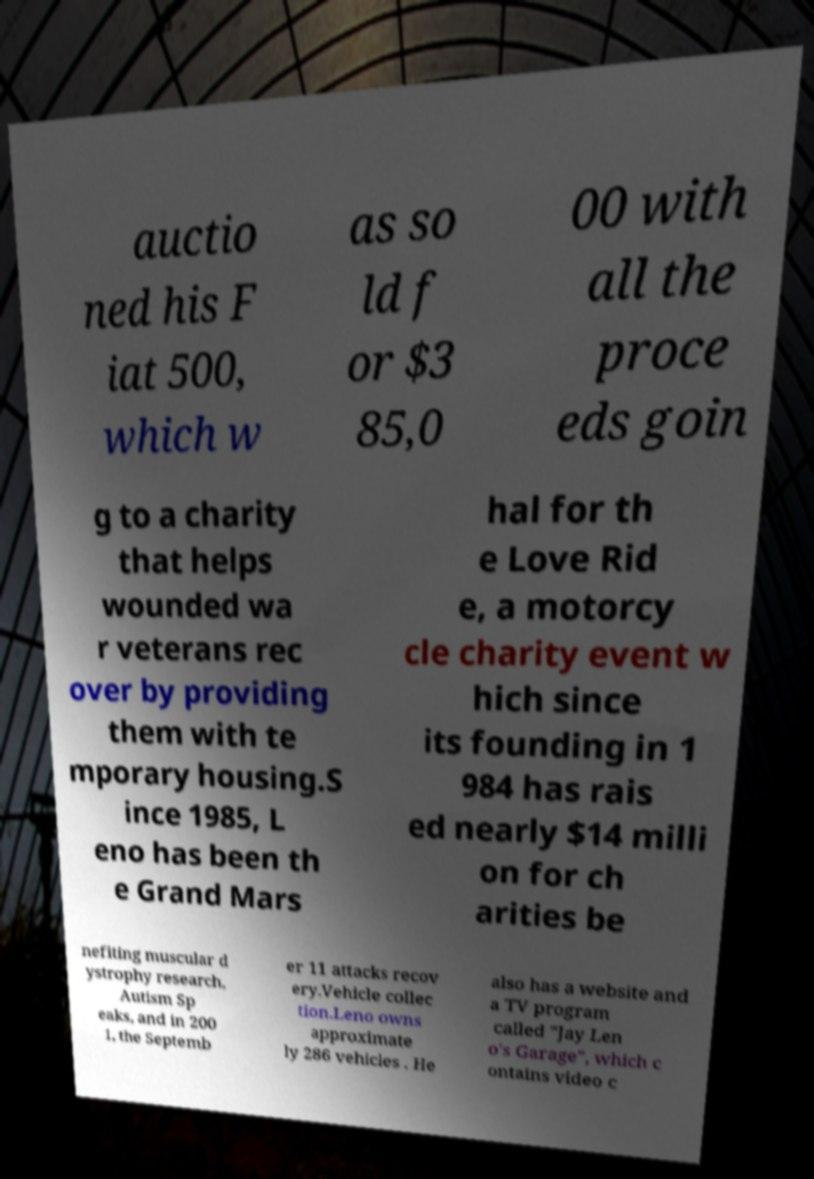There's text embedded in this image that I need extracted. Can you transcribe it verbatim? auctio ned his F iat 500, which w as so ld f or $3 85,0 00 with all the proce eds goin g to a charity that helps wounded wa r veterans rec over by providing them with te mporary housing.S ince 1985, L eno has been th e Grand Mars hal for th e Love Rid e, a motorcy cle charity event w hich since its founding in 1 984 has rais ed nearly $14 milli on for ch arities be nefiting muscular d ystrophy research, Autism Sp eaks, and in 200 1, the Septemb er 11 attacks recov ery.Vehicle collec tion.Leno owns approximate ly 286 vehicles . He also has a website and a TV program called "Jay Len o's Garage", which c ontains video c 